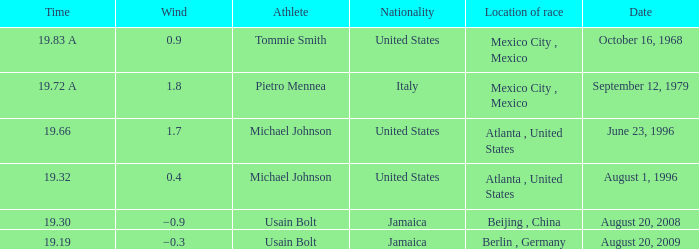32? 0.4. 